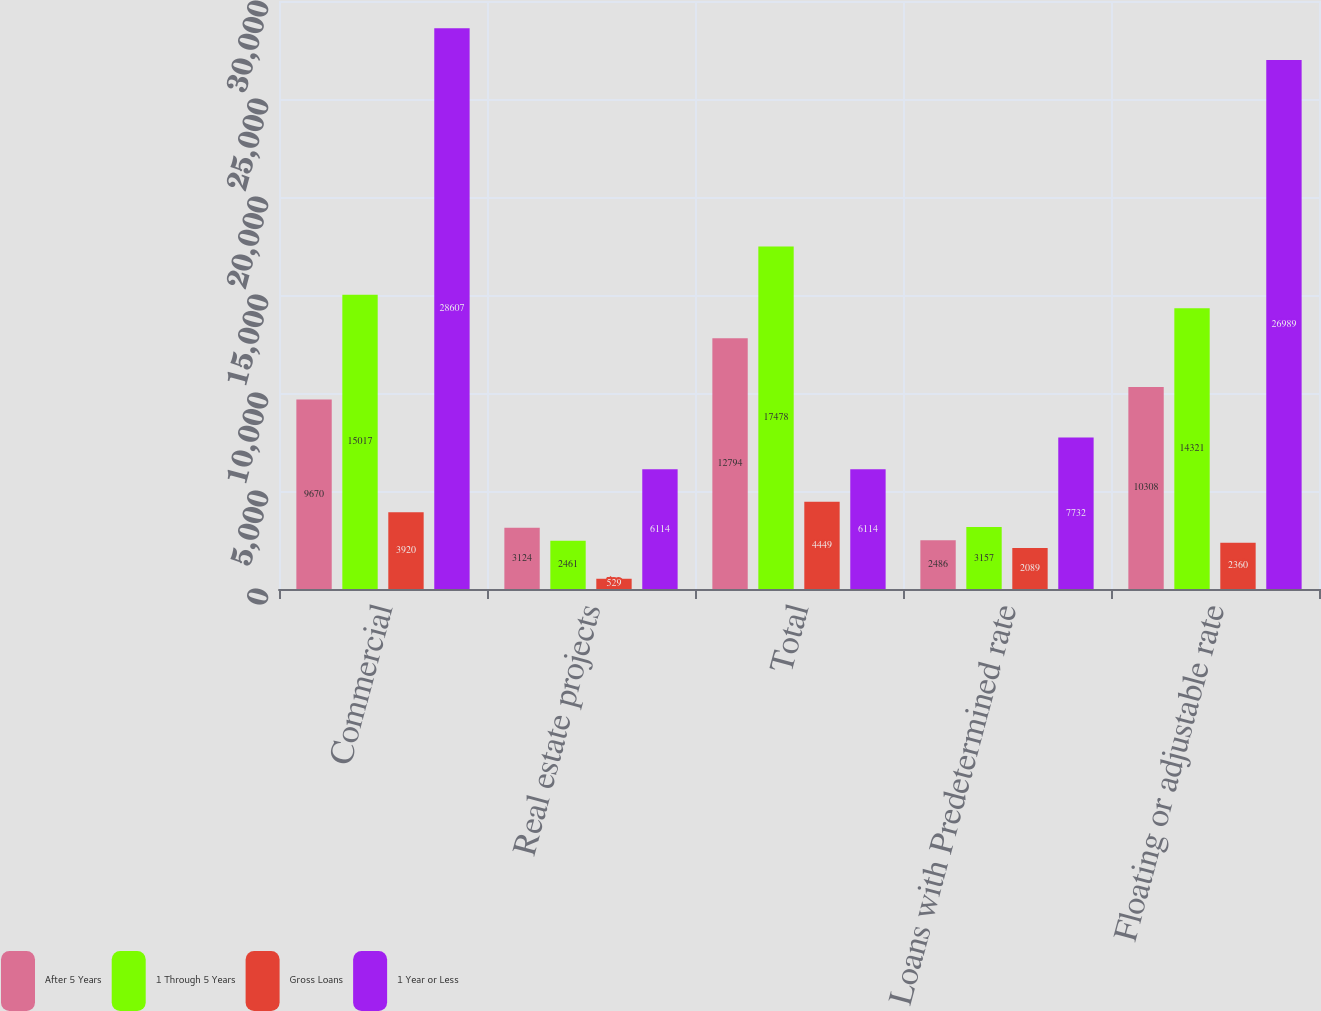Convert chart to OTSL. <chart><loc_0><loc_0><loc_500><loc_500><stacked_bar_chart><ecel><fcel>Commercial<fcel>Real estate projects<fcel>Total<fcel>Loans with Predetermined rate<fcel>Floating or adjustable rate<nl><fcel>After 5 Years<fcel>9670<fcel>3124<fcel>12794<fcel>2486<fcel>10308<nl><fcel>1 Through 5 Years<fcel>15017<fcel>2461<fcel>17478<fcel>3157<fcel>14321<nl><fcel>Gross Loans<fcel>3920<fcel>529<fcel>4449<fcel>2089<fcel>2360<nl><fcel>1 Year or Less<fcel>28607<fcel>6114<fcel>6114<fcel>7732<fcel>26989<nl></chart> 